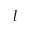<formula> <loc_0><loc_0><loc_500><loc_500>l</formula> 